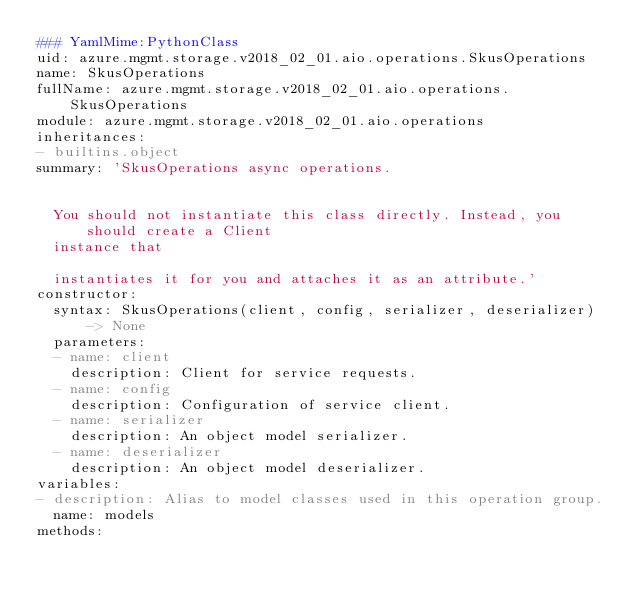<code> <loc_0><loc_0><loc_500><loc_500><_YAML_>### YamlMime:PythonClass
uid: azure.mgmt.storage.v2018_02_01.aio.operations.SkusOperations
name: SkusOperations
fullName: azure.mgmt.storage.v2018_02_01.aio.operations.SkusOperations
module: azure.mgmt.storage.v2018_02_01.aio.operations
inheritances:
- builtins.object
summary: 'SkusOperations async operations.


  You should not instantiate this class directly. Instead, you should create a Client
  instance that

  instantiates it for you and attaches it as an attribute.'
constructor:
  syntax: SkusOperations(client, config, serializer, deserializer) -> None
  parameters:
  - name: client
    description: Client for service requests.
  - name: config
    description: Configuration of service client.
  - name: serializer
    description: An object model serializer.
  - name: deserializer
    description: An object model deserializer.
variables:
- description: Alias to model classes used in this operation group.
  name: models
methods:</code> 